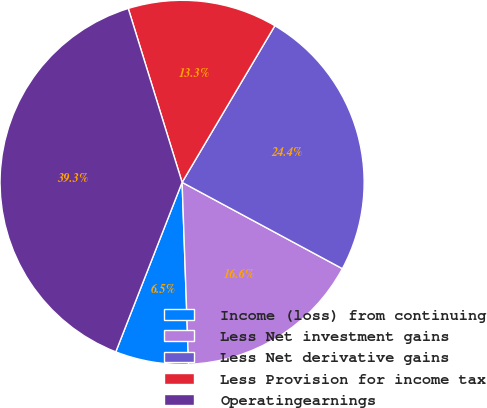Convert chart. <chart><loc_0><loc_0><loc_500><loc_500><pie_chart><fcel>Income (loss) from continuing<fcel>Less Net investment gains<fcel>Less Net derivative gains<fcel>Less Provision for income tax<fcel>Operatingearnings<nl><fcel>6.5%<fcel>16.57%<fcel>24.35%<fcel>13.29%<fcel>39.28%<nl></chart> 